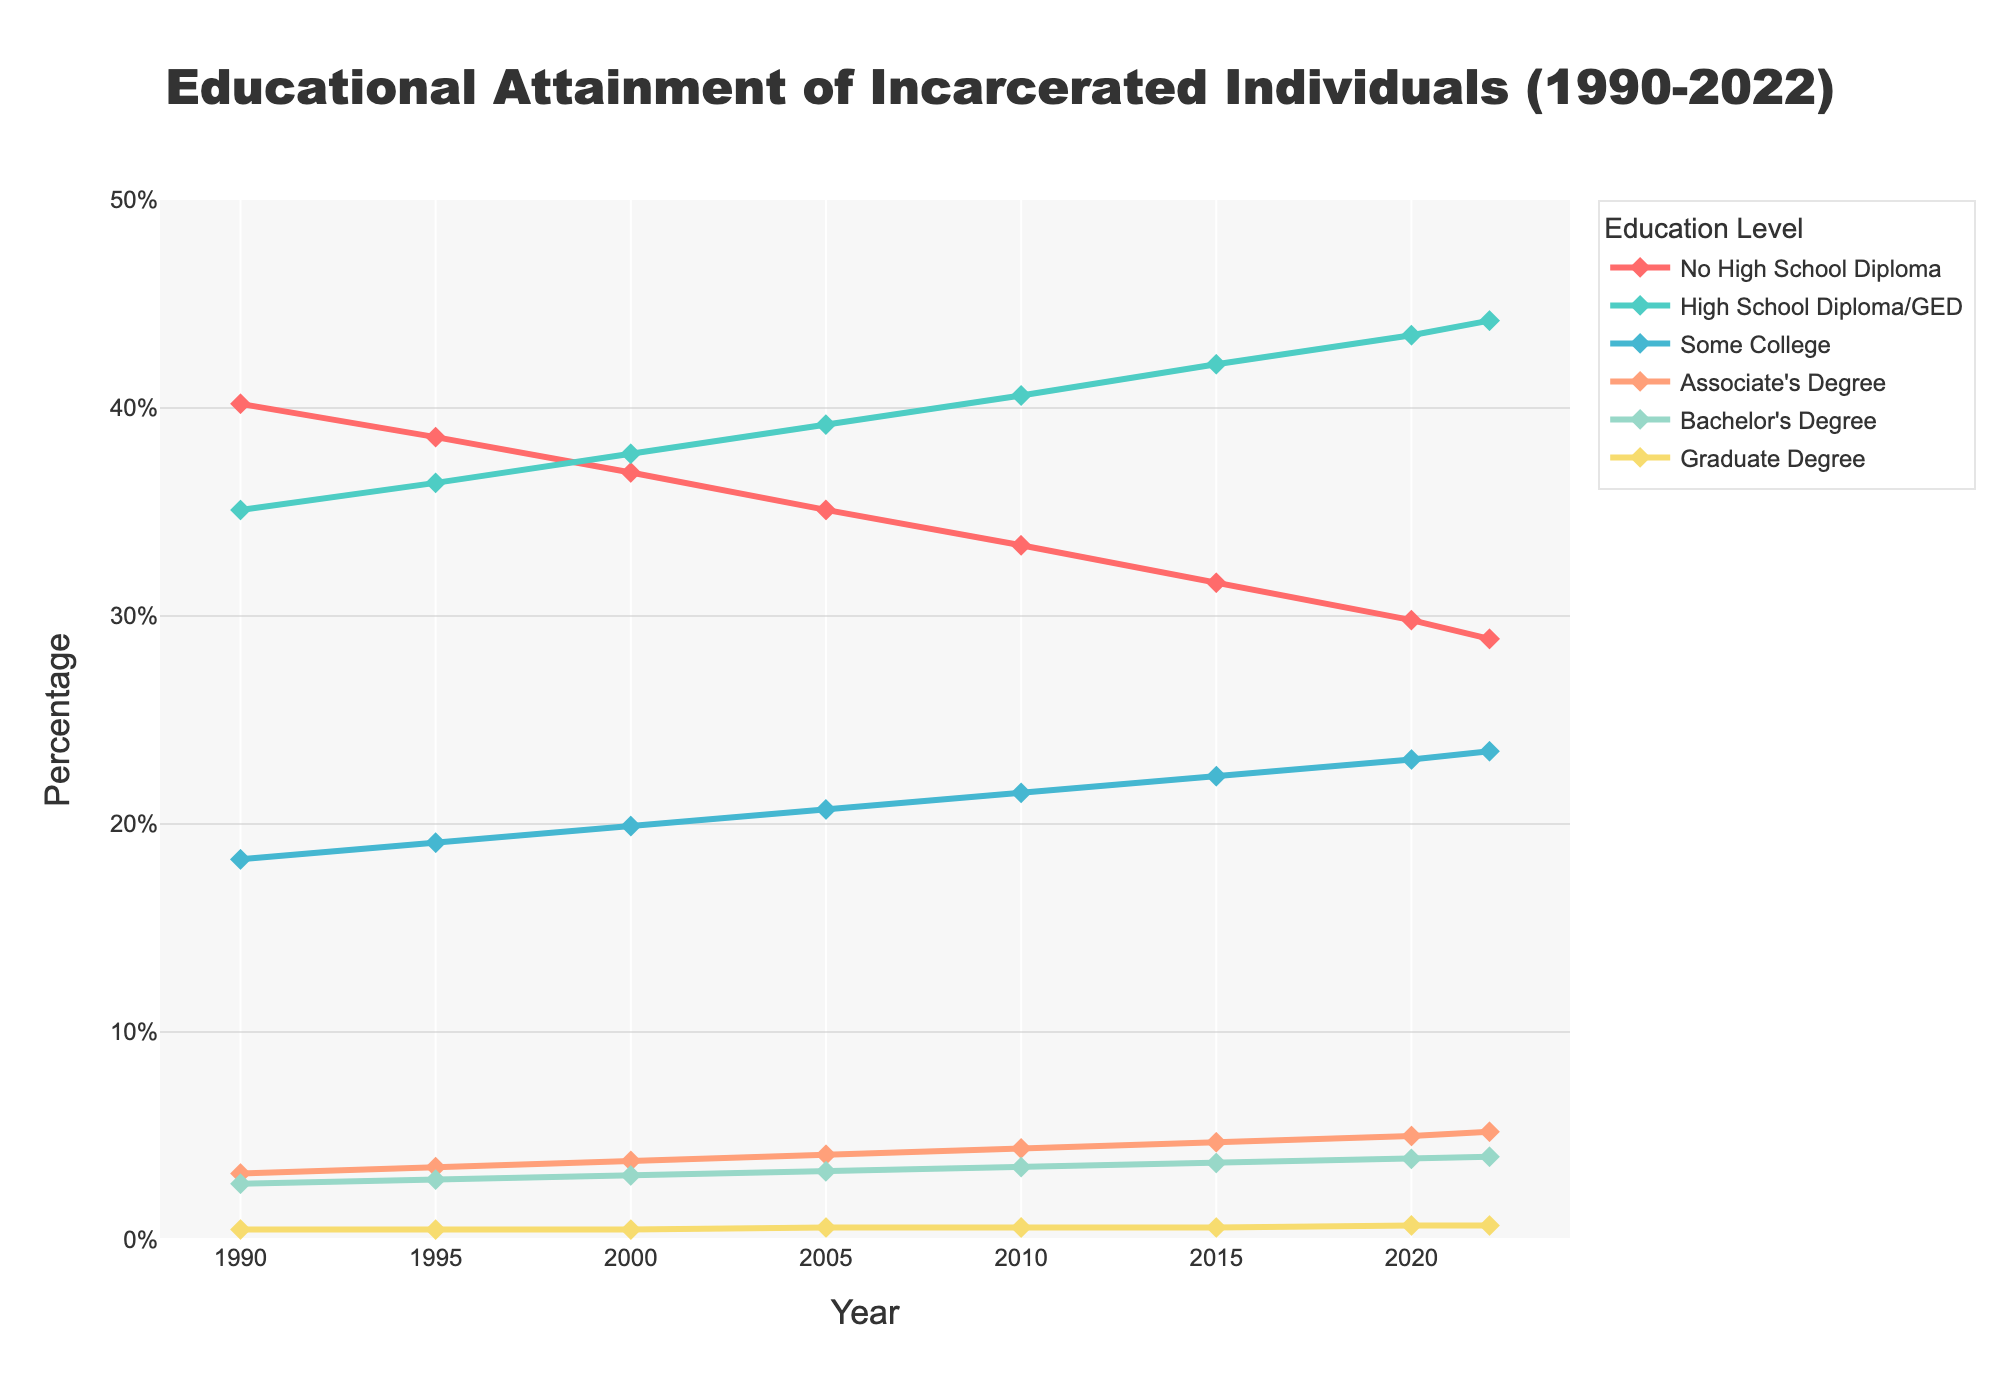What is the percentage change in individuals with no high school diploma from 1990 to 2022? To find the percentage change, subtract the initial value in 1990 (40.2%) from the final value in 2022 (28.9%), and then divide by the initial value, finally multiply by 100. (28.9 - 40.2) / 40.2 * 100 = -27.86%
Answer: -27.86% Which education level showed the most significant increase in percentage from 1990 to 2022? First, calculate the percentage increase for each education level from 1990 to 2022. The largest increase is in the "High School Diploma/GED" category, going from 35.1% to 44.2%.
Answer: High School Diploma/GED How did the percentage of individuals with an Associate's Degree change from 1990 to 2022? Find the percentage for Associate's Degree in 1990 (3.2%) and in 2022 (5.2%). Subtract the 1990 value from the 2022 value to get the change: 5.2% - 3.2% = 2.0%
Answer: Increased by 2.0% Compare the trends of Bachelor's and Graduate degrees from 1990 to 2022. What do you notice? Both Bachelor's (from 2.7% to 4.0%) and Graduate degrees (from 0.5% to 0.7%) show an upward trend. However, the increase for Bachelor's degrees is more significant compared to Graduate degrees.
Answer: Bachelor's degree increased more significantly What is the sum of percentages for individuals with some college and those with an Associate's Degree in 2022? Add the percentages for Some College (23.5%) and Associate's Degree (5.2%) in 2022. 23.5 + 5.2 = 28.7%.
Answer: 28.7% Which education level had the least change in percentage from 1990 to 2022? By comparing the changes for all education levels, we see that the Graduate Degree category changed least, from 0.5% to 0.7% over the period.
Answer: Graduate Degree By how much did the percentage of individuals with a High School Diploma/GED increase from 2005 to 2022? Subtract the percentage in 2005 (39.2%) from the percentage in 2022 (44.2%). 44.2 - 39.2 = 5.0
Answer: 5.0% In what year did the percentage of individuals with no high school diploma drop below 30%? Observing the line for "No High School Diploma," we see it drops below 30% in the year 2020.
Answer: 2020 